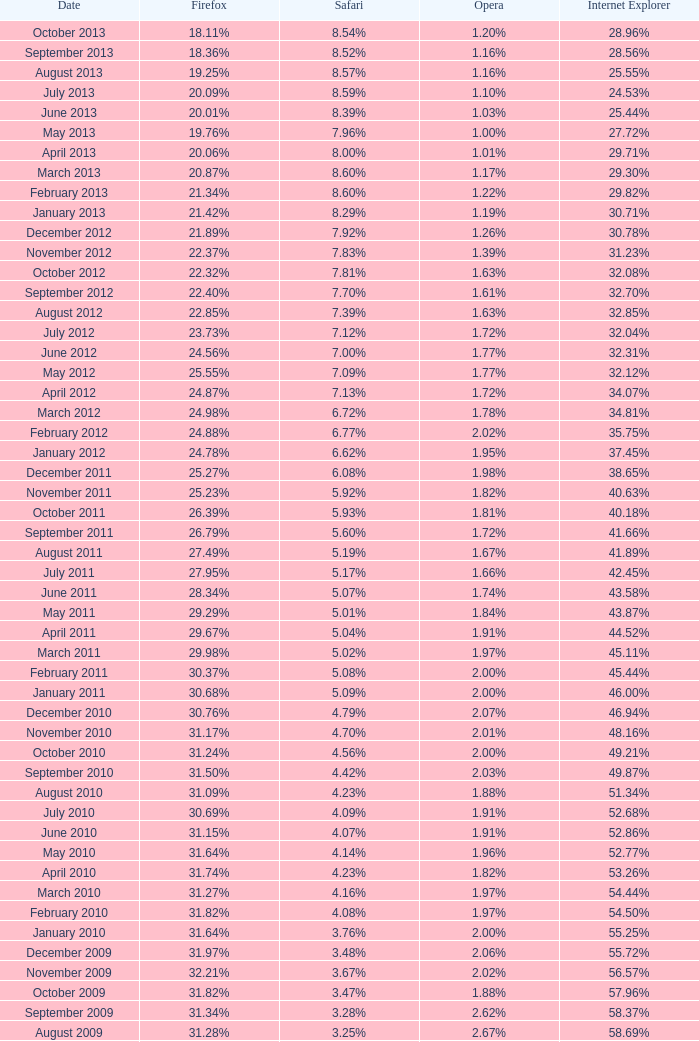What percentage of browsers were using Opera in October 2010? 2.00%. 